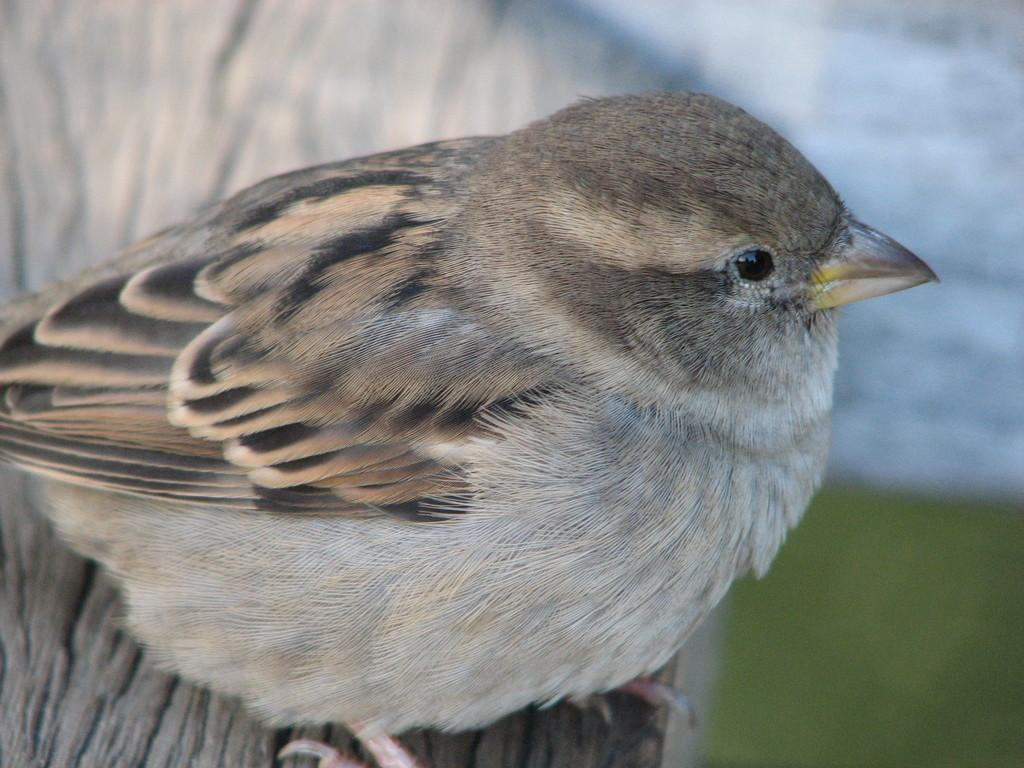What type of animal can be seen in the image? There is a bird in the image. Where is the bird located in the image? The bird is on the surface in the image. How does the bird pump water in the image? There is no pump or water present in the image; the bird is simply on the surface. 